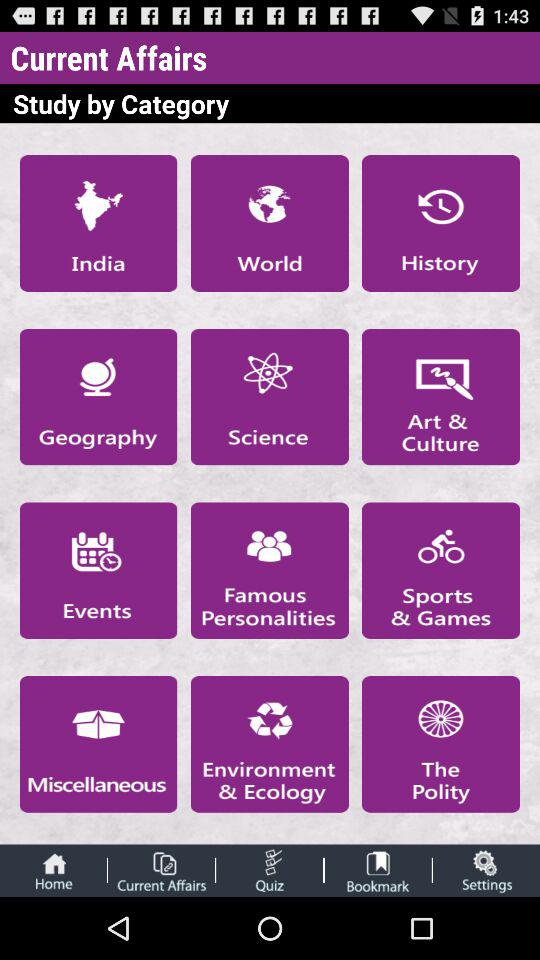What are the different categories displayed for current affairs? The different categories displayed for current affairs are "India", "World", "History", "Geography", "Science", "Art & Culture", "Events", "Famous Personalities", "Sports & Games", "Miscellaneous", "Environment & Ecology" and "The Polity". 